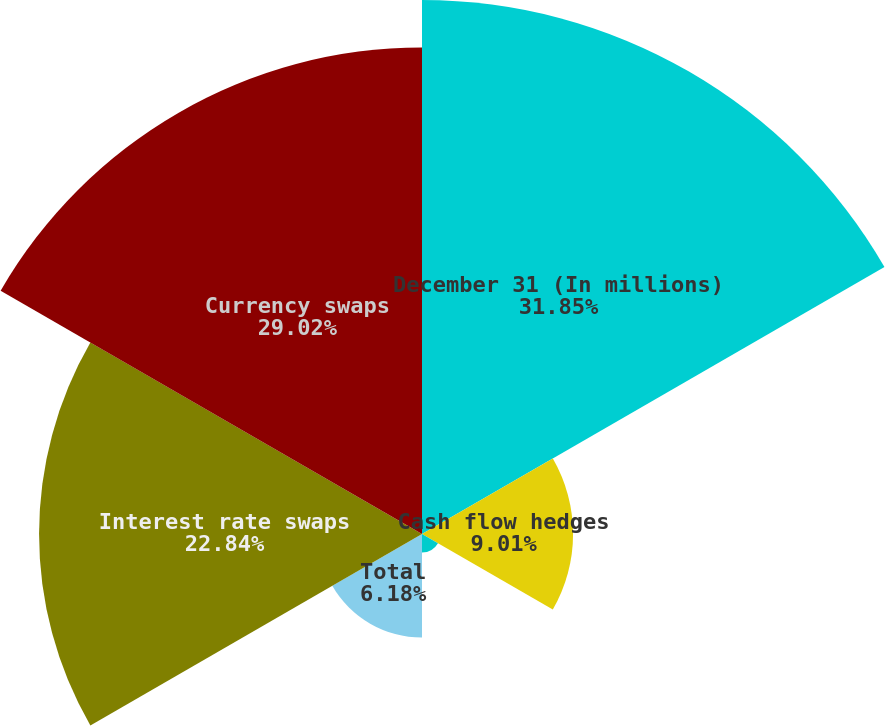Convert chart to OTSL. <chart><loc_0><loc_0><loc_500><loc_500><pie_chart><fcel>December 31 (In millions)<fcel>Cash flow hedges<fcel>Fair value hedges<fcel>Total<fcel>Interest rate swaps<fcel>Currency swaps<nl><fcel>31.85%<fcel>9.01%<fcel>1.1%<fcel>6.18%<fcel>22.84%<fcel>29.02%<nl></chart> 